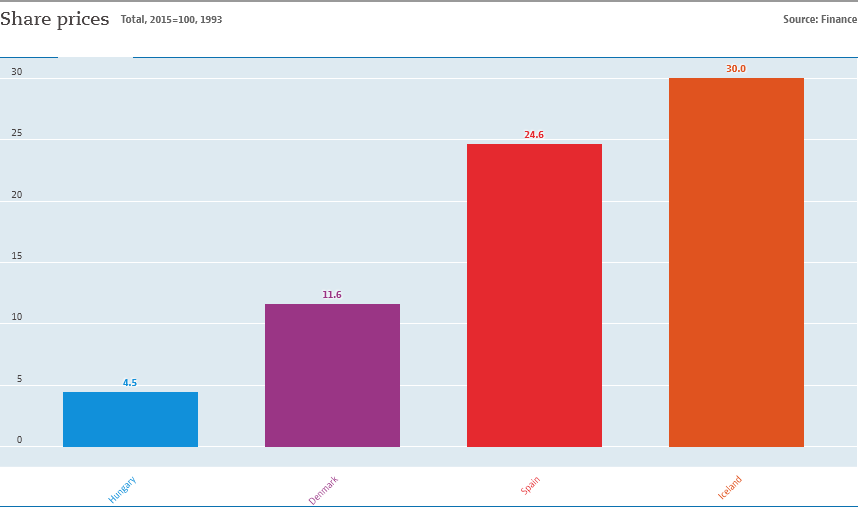Point out several critical features in this image. The average of Hungary, Denmark, and Spain is approximately 0.1356. Four countries are represented in this graph. 